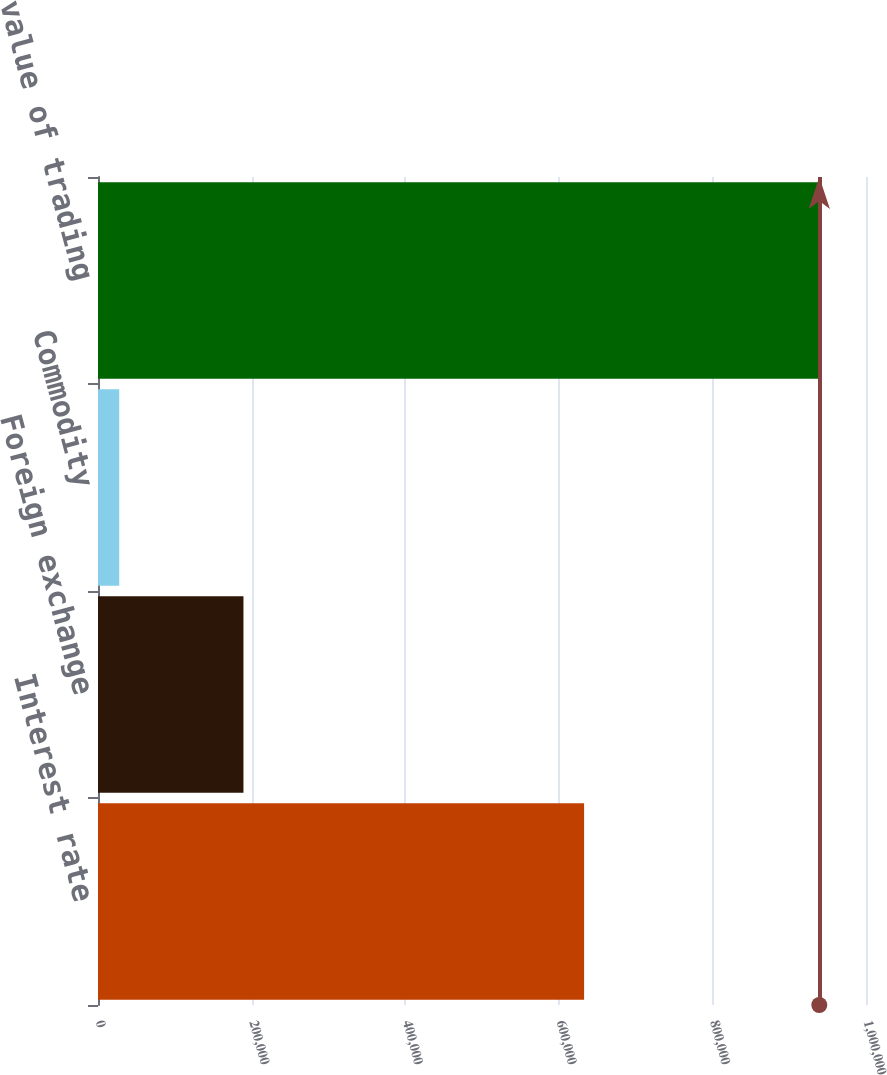Convert chart to OTSL. <chart><loc_0><loc_0><loc_500><loc_500><bar_chart><fcel>Interest rate<fcel>Foreign exchange<fcel>Commodity<fcel>Total fair value of trading<nl><fcel>632928<fcel>189397<fcel>27653<fcel>939170<nl></chart> 